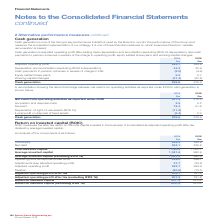According to Spirax Sarco Engineering Plc's financial document, What does the ROIC measure? the after tax return on the total capital invested in the business. The document states: "Return on invested capital (ROIC) ROIC measures the after tax return on the total capital invested in the business. It is calculated as adjusted opera..." Also, How is the ROIC calculated? adjusted operating profit after tax divided by average invested capital. The document states: "tal invested in the business. It is calculated as adjusted operating profit after tax divided by average invested capital...." Also, What are the components factored in when calculating the total invested capital? The document shows two values: Total equity and Net debt. From the document: "2018 £m Total equity 826.3 766.9 Net debt 334.1 235.8 Total invested capital 1,160.4 1,002.7 Average invested capital 1,081.6 992.9 Average i 2018 £m ..." Additionally, In which year was the amount of adjusted operating profit after tax (excluding IFRS 16) larger? According to the financial document, 2019. The relevant text states: "Spirax-Sarco Engineering plc Annual Report 2019..." Also, can you calculate: What is the change in net debt in 2019 from 2018? Based on the calculation: 334.1-235.8, the result is 98.3 (in millions). This is based on the information: "2018 £m Total equity 826.3 766.9 Net debt 334.1 235.8 Total invested capital 1,160.4 1,002.7 Average invested capital 1,081.6 992.9 Average investe 2018 £m Total equity 826.3 766.9 Net debt 334.1 235...." The key data points involved are: 235.8, 334.1. Also, can you calculate: What is the percentage change in net debt in 2019 from 2018? To answer this question, I need to perform calculations using the financial data. The calculation is: (334.1-235.8)/235.8, which equals 41.69 (percentage). This is based on the information: "2018 £m Total equity 826.3 766.9 Net debt 334.1 235.8 Total invested capital 1,160.4 1,002.7 Average invested capital 1,081.6 992.9 Average investe 2018 £m Total equity 826.3 766.9 Net debt 334.1 235...." The key data points involved are: 235.8, 334.1. 